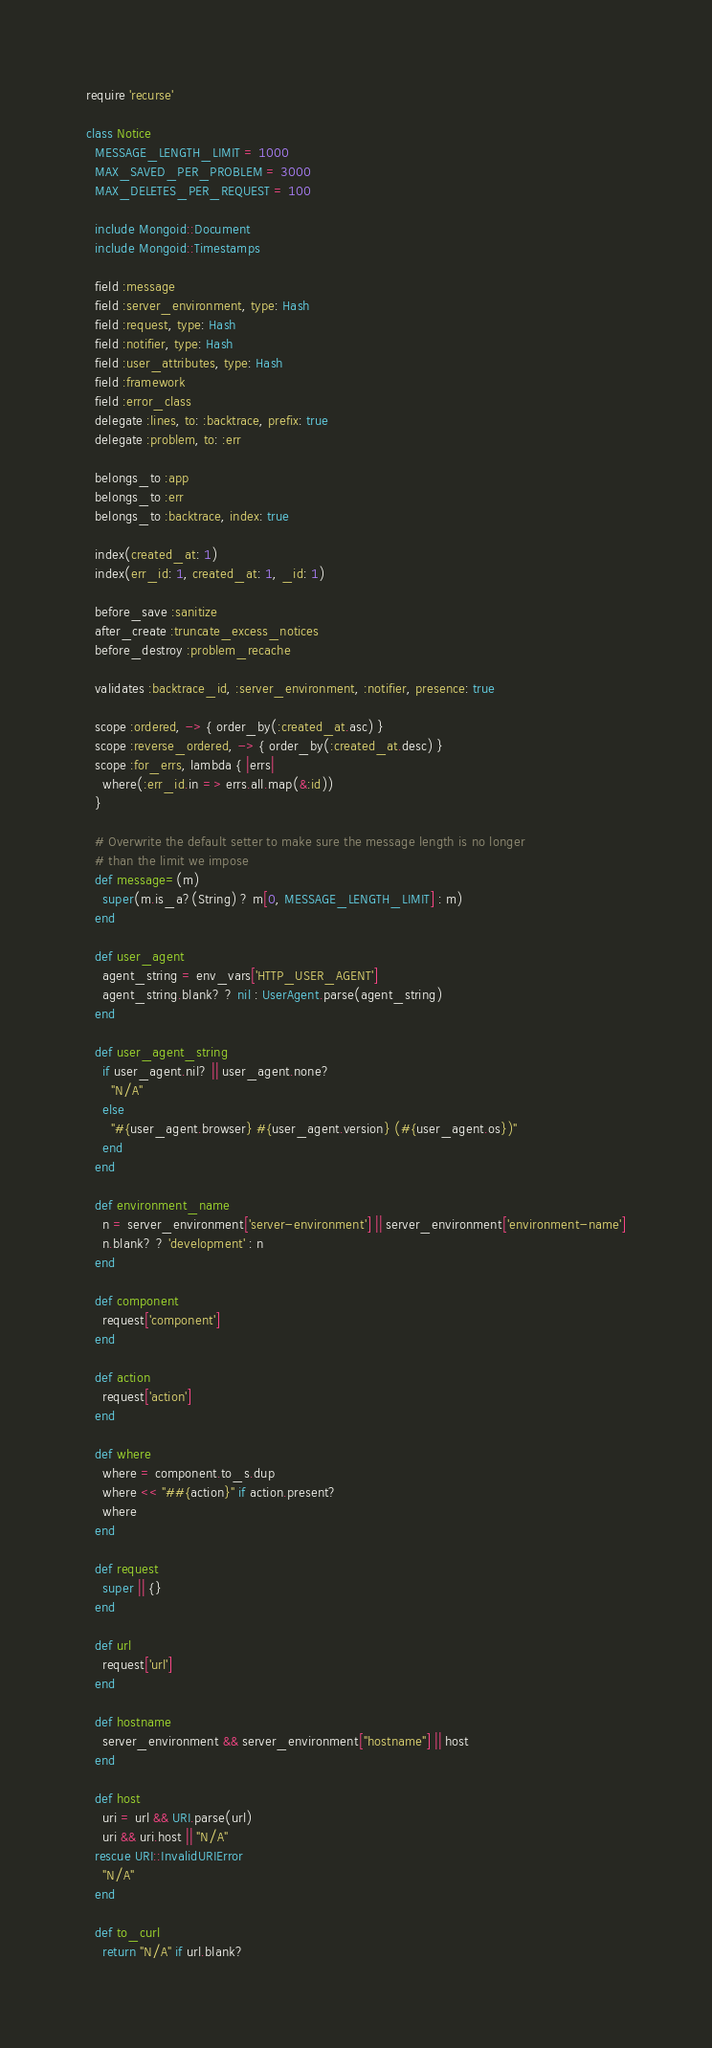<code> <loc_0><loc_0><loc_500><loc_500><_Ruby_>require 'recurse'

class Notice
  MESSAGE_LENGTH_LIMIT = 1000
  MAX_SAVED_PER_PROBLEM = 3000
  MAX_DELETES_PER_REQUEST = 100

  include Mongoid::Document
  include Mongoid::Timestamps

  field :message
  field :server_environment, type: Hash
  field :request, type: Hash
  field :notifier, type: Hash
  field :user_attributes, type: Hash
  field :framework
  field :error_class
  delegate :lines, to: :backtrace, prefix: true
  delegate :problem, to: :err

  belongs_to :app
  belongs_to :err
  belongs_to :backtrace, index: true

  index(created_at: 1)
  index(err_id: 1, created_at: 1, _id: 1)

  before_save :sanitize
  after_create :truncate_excess_notices
  before_destroy :problem_recache

  validates :backtrace_id, :server_environment, :notifier, presence: true

  scope :ordered, -> { order_by(:created_at.asc) }
  scope :reverse_ordered, -> { order_by(:created_at.desc) }
  scope :for_errs, lambda { |errs|
    where(:err_id.in => errs.all.map(&:id))
  }

  # Overwrite the default setter to make sure the message length is no longer
  # than the limit we impose
  def message=(m)
    super(m.is_a?(String) ? m[0, MESSAGE_LENGTH_LIMIT] : m)
  end

  def user_agent
    agent_string = env_vars['HTTP_USER_AGENT']
    agent_string.blank? ? nil : UserAgent.parse(agent_string)
  end

  def user_agent_string
    if user_agent.nil? || user_agent.none?
      "N/A"
    else
      "#{user_agent.browser} #{user_agent.version} (#{user_agent.os})"
    end
  end

  def environment_name
    n = server_environment['server-environment'] || server_environment['environment-name']
    n.blank? ? 'development' : n
  end

  def component
    request['component']
  end

  def action
    request['action']
  end

  def where
    where = component.to_s.dup
    where << "##{action}" if action.present?
    where
  end

  def request
    super || {}
  end

  def url
    request['url']
  end

  def hostname
    server_environment && server_environment["hostname"] || host
  end

  def host
    uri = url && URI.parse(url)
    uri && uri.host || "N/A"
  rescue URI::InvalidURIError
    "N/A"
  end

  def to_curl
    return "N/A" if url.blank?</code> 